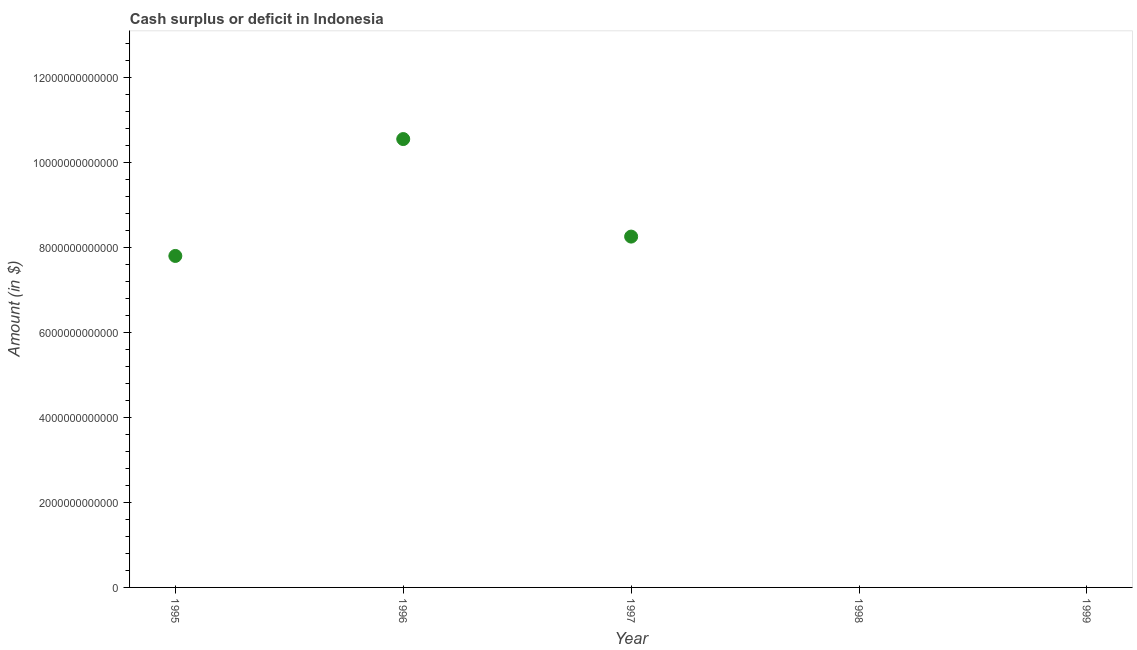What is the cash surplus or deficit in 1997?
Make the answer very short. 8.26e+12. Across all years, what is the maximum cash surplus or deficit?
Offer a terse response. 1.06e+13. Across all years, what is the minimum cash surplus or deficit?
Offer a very short reply. 0. In which year was the cash surplus or deficit maximum?
Provide a short and direct response. 1996. What is the sum of the cash surplus or deficit?
Offer a very short reply. 2.66e+13. What is the difference between the cash surplus or deficit in 1995 and 1997?
Your answer should be compact. -4.56e+11. What is the average cash surplus or deficit per year?
Offer a very short reply. 5.32e+12. What is the median cash surplus or deficit?
Your response must be concise. 7.80e+12. What is the ratio of the cash surplus or deficit in 1995 to that in 1997?
Make the answer very short. 0.94. Is the cash surplus or deficit in 1995 less than that in 1997?
Keep it short and to the point. Yes. What is the difference between the highest and the second highest cash surplus or deficit?
Give a very brief answer. 2.30e+12. Is the sum of the cash surplus or deficit in 1995 and 1996 greater than the maximum cash surplus or deficit across all years?
Provide a succinct answer. Yes. What is the difference between the highest and the lowest cash surplus or deficit?
Your answer should be compact. 1.06e+13. In how many years, is the cash surplus or deficit greater than the average cash surplus or deficit taken over all years?
Offer a terse response. 3. Does the cash surplus or deficit monotonically increase over the years?
Your response must be concise. No. How many dotlines are there?
Provide a short and direct response. 1. How many years are there in the graph?
Provide a succinct answer. 5. What is the difference between two consecutive major ticks on the Y-axis?
Give a very brief answer. 2.00e+12. Are the values on the major ticks of Y-axis written in scientific E-notation?
Provide a short and direct response. No. Does the graph contain any zero values?
Keep it short and to the point. Yes. What is the title of the graph?
Provide a short and direct response. Cash surplus or deficit in Indonesia. What is the label or title of the Y-axis?
Ensure brevity in your answer.  Amount (in $). What is the Amount (in $) in 1995?
Make the answer very short. 7.80e+12. What is the Amount (in $) in 1996?
Offer a terse response. 1.06e+13. What is the Amount (in $) in 1997?
Provide a succinct answer. 8.26e+12. What is the Amount (in $) in 1998?
Your answer should be compact. 0. What is the Amount (in $) in 1999?
Offer a very short reply. 0. What is the difference between the Amount (in $) in 1995 and 1996?
Your response must be concise. -2.75e+12. What is the difference between the Amount (in $) in 1995 and 1997?
Your answer should be very brief. -4.56e+11. What is the difference between the Amount (in $) in 1996 and 1997?
Provide a succinct answer. 2.30e+12. What is the ratio of the Amount (in $) in 1995 to that in 1996?
Ensure brevity in your answer.  0.74. What is the ratio of the Amount (in $) in 1995 to that in 1997?
Give a very brief answer. 0.94. What is the ratio of the Amount (in $) in 1996 to that in 1997?
Your response must be concise. 1.28. 